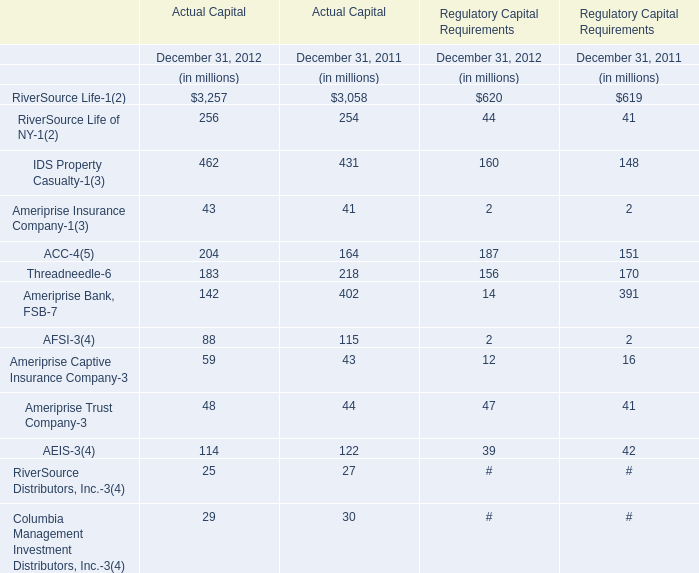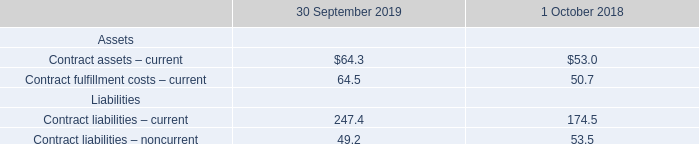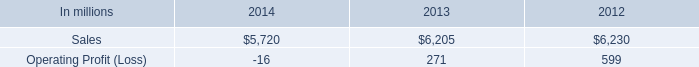what percentage where brazilian papers net sales of printing papers sales in 2014? 
Computations: ((1.1 * 1000) / 5720)
Answer: 0.19231. 